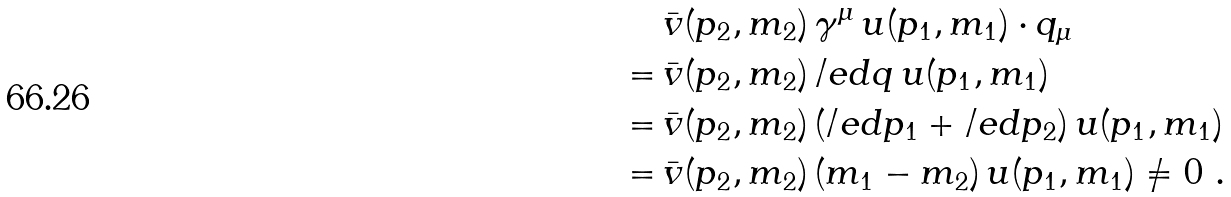Convert formula to latex. <formula><loc_0><loc_0><loc_500><loc_500>& \, \bar { v } ( p _ { 2 } , m _ { 2 } ) \, \gamma ^ { \mu } \, u ( p _ { 1 } , m _ { 1 } ) \cdot q _ { \mu } \\ = & \, \bar { v } ( p _ { 2 } , m _ { 2 } ) \, \slash e d { q } \, u ( p _ { 1 } , m _ { 1 } ) \\ = & \, \bar { v } ( p _ { 2 } , m _ { 2 } ) \, ( \slash e d { p } _ { 1 } + \slash e d { p } _ { 2 } ) \, u ( p _ { 1 } , m _ { 1 } ) \\ = & \, \bar { v } ( p _ { 2 } , m _ { 2 } ) \, ( m _ { 1 } - m _ { 2 } ) \, u ( p _ { 1 } , m _ { 1 } ) \neq 0 \ .</formula> 